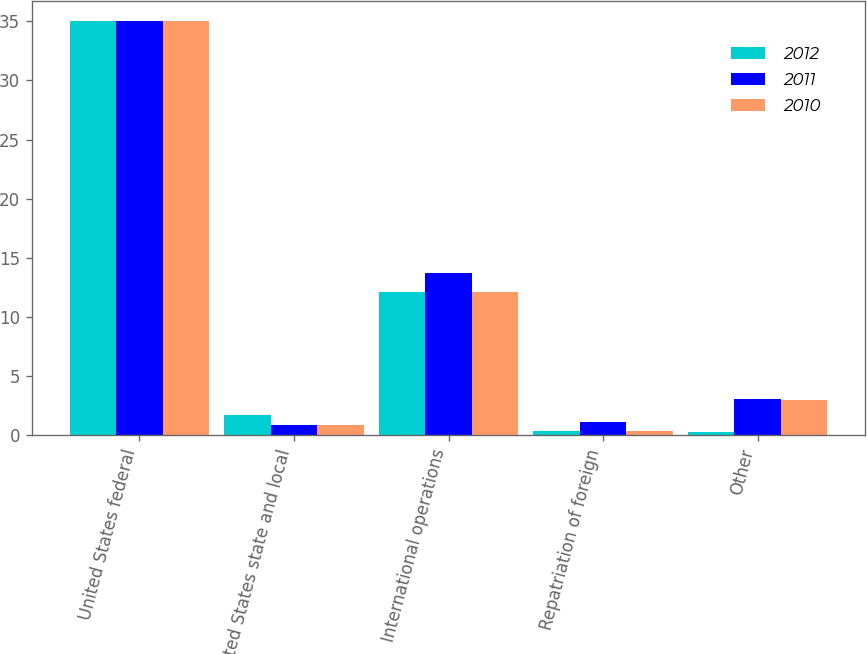Convert chart to OTSL. <chart><loc_0><loc_0><loc_500><loc_500><stacked_bar_chart><ecel><fcel>United States federal<fcel>United States state and local<fcel>International operations<fcel>Repatriation of foreign<fcel>Other<nl><fcel>2012<fcel>35<fcel>1.7<fcel>12.1<fcel>0.4<fcel>0.3<nl><fcel>2011<fcel>35<fcel>0.9<fcel>13.7<fcel>1.1<fcel>3.1<nl><fcel>2010<fcel>35<fcel>0.9<fcel>12.1<fcel>0.4<fcel>3<nl></chart> 